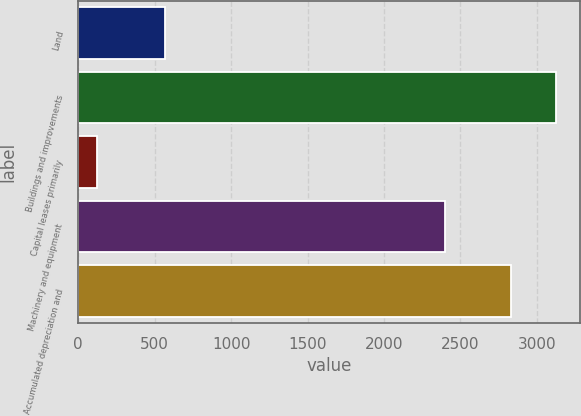Convert chart to OTSL. <chart><loc_0><loc_0><loc_500><loc_500><bar_chart><fcel>Land<fcel>Buildings and improvements<fcel>Capital leases primarily<fcel>Machinery and equipment<fcel>Accumulated depreciation and<nl><fcel>567<fcel>3126.8<fcel>126<fcel>2399<fcel>2830<nl></chart> 